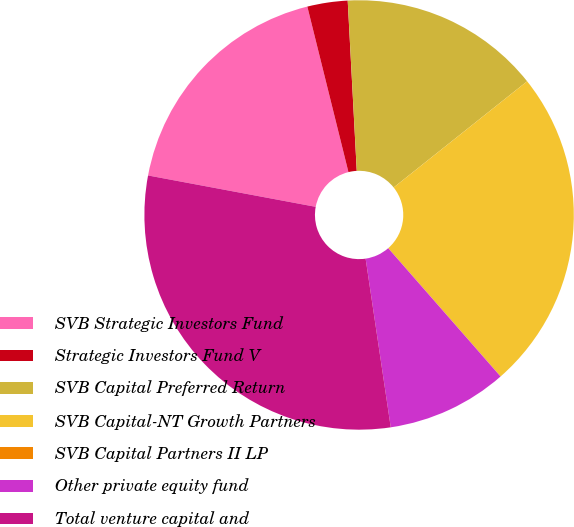Convert chart. <chart><loc_0><loc_0><loc_500><loc_500><pie_chart><fcel>SVB Strategic Investors Fund<fcel>Strategic Investors Fund V<fcel>SVB Capital Preferred Return<fcel>SVB Capital-NT Growth Partners<fcel>SVB Capital Partners II LP<fcel>Other private equity fund<fcel>Total venture capital and<nl><fcel>18.18%<fcel>3.03%<fcel>15.15%<fcel>24.24%<fcel>0.01%<fcel>9.09%<fcel>30.3%<nl></chart> 